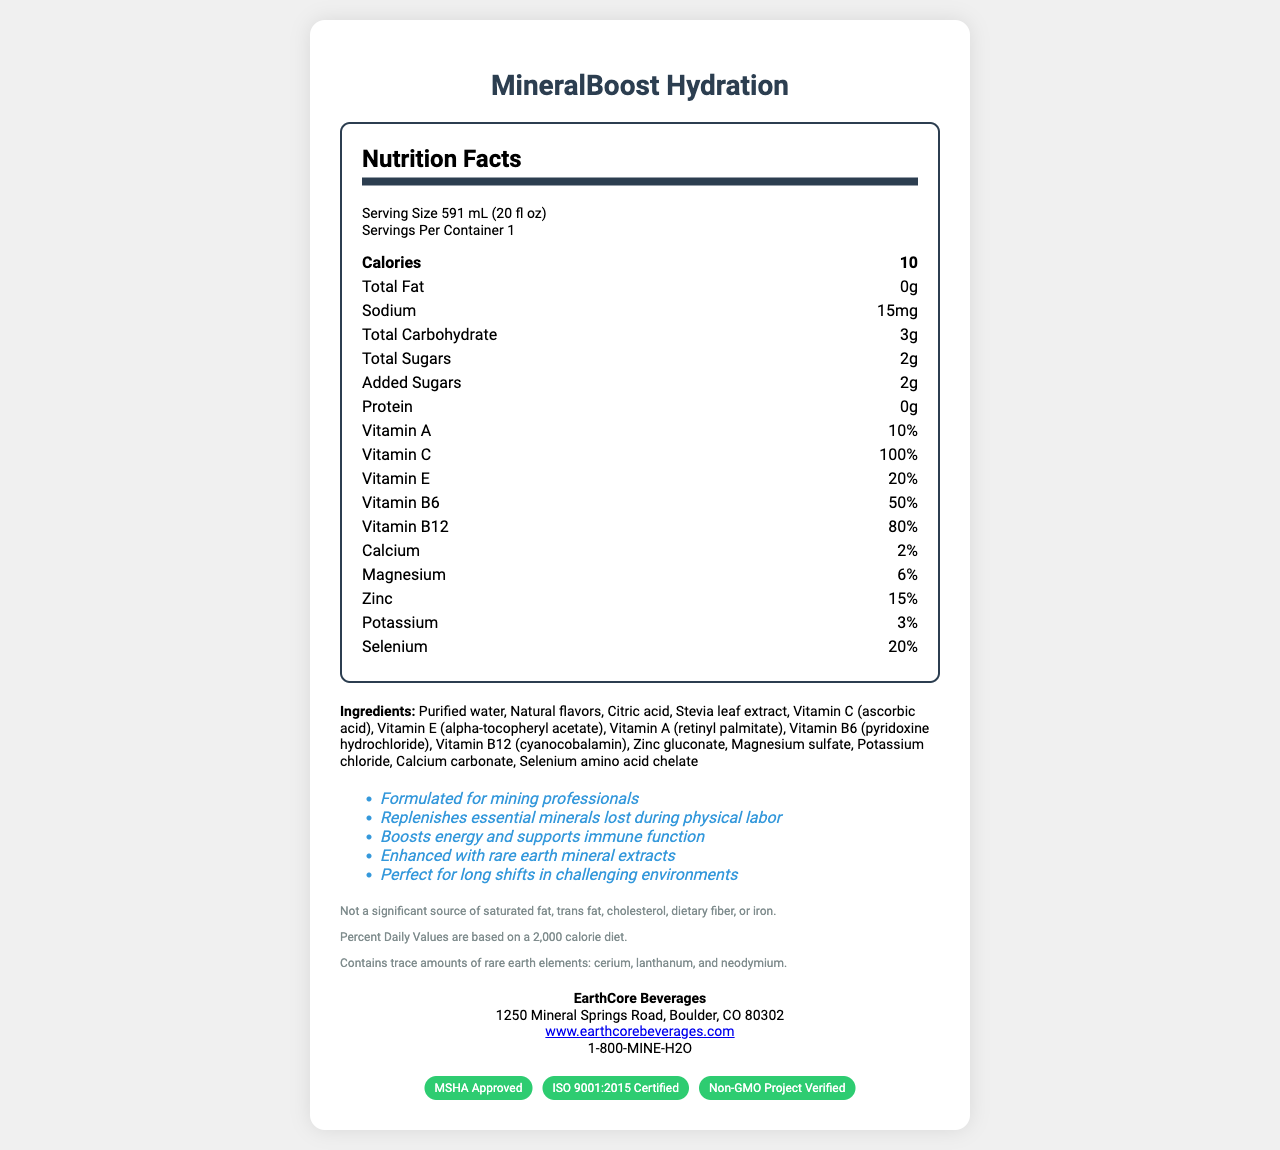What is the serving size of MineralBoost Hydration? The serving size is clearly indicated at the top of the Nutrition Facts section.
Answer: 591 mL (20 fl oz) How many calories are there per serving? The document lists the calories at the top of the nutrition facts as "10".
Answer: 10 What are the ingredients in MineralBoost Hydration? The ingredients are listed in the ingredients section of the document.
Answer: Purified water, Natural flavors, Citric acid, Stevia leaf extract, Vitamin C (ascorbic acid), Vitamin E (alpha-tocopheryl acetate), Vitamin A (retinyl palmitate), Vitamin B6 (pyridoxine hydrochloride), Vitamin B12 (cyanocobalamin), Zinc gluconate, Magnesium sulfate, Potassium chloride, Calcium carbonate, Selenium amino acid chelate What is the percentage of daily Vitamin C provided by MineralBoost Hydration? The nutrition facts list Vitamin C as providing 100% of the daily value.
Answer: 100% Who manufactures MineralBoost Hydration? The manufacturer's information is listed near the bottom of the document.
Answer: EarthCore Beverages (Short-answer) How much sodium is in one serving of MineralBoost Hydration? The nutrition facts list sodium content as 15mg per serving.
Answer: 15mg (Short-answer) What are the marketing claims made by MineralBoost Hydration? The marketing claims are listed in the claims section of the document.
Answer: 1. Formulated for mining professionals 2. Replenishes essential minerals lost during physical labor 3. Boosts energy and supports immune function 4. Enhanced with rare earth mineral extracts 5. Perfect for long shifts in challenging environments (Short-answer) What certifications does MineralBoost Hydration have? The certifications are listed at the bottom of the document under the certifications section.
Answer: MSHA Approved, ISO 9001:2015 Certified, Non-GMO Project Verified (Short-answer) What rare earth elements are trace amounts of in MineralBoost Hydration? The disclaimers section mentions that the product contains trace amounts of rare earth elements: cerium, lanthanum, and neodymium.
Answer: Cerium, Lanthanum, Neodymium (Yes/No) Does MineralBoost Hydration contain any protein? The nutrition facts specifically state that there is 0g of protein in the product.
Answer: No (Multiple-choice) What amount of Vitamin B6 is in this product as a percentage of daily value? 
A. 10% 
B. 80% 
C. 50% The nutrition facts list Vitamin B6 as providing 50% of the daily value.
Answer: C (Multiple-choice) Which of the following minerals is present in the smallest percentage of daily value in MineralBoost Hydration? 
1. Calcium 
2. Magnesium 
3. Zinc 
4. Potassium The nutrition facts list Calcium as 2%, Magnesium as 6%, Zinc as 15%, and Potassium as 3%. Therefore, Calcium is present in the smallest percentage of daily value.
Answer: 1 (Summary) Summarize the main purposes and notable aspects of this vitamin-enhanced water product. The summary captures the main idea that MineralBoost Hydration targets mining professionals with its blend of vitamins, minerals, and claims of replenishing and energy-boosting effects. It also mentions its certifications.
Answer: MineralBoost Hydration is a vitamin-enhanced water specifically formulated for mining professionals. It contains 10 calories per serving and offers various vitamins and minerals including 100% of the daily value of Vitamin C, and significant percentages of several B vitamins, Vitamin E, and Vitamin A. It also includes minor amounts of rare earth elements like cerium, lanthanum, and neodymium. The product is marketed as replenishing essential minerals lost during physical labor, boosting energy, and supporting immune function, and is MSHA Approved, ISO 9001:2015 Certified, and Non-GMO Project Verified. (Unanswerable) What is the best-selling product line of EarthCore Beverages? The provided document does not contain any information regarding the sales performance of this or any other product line from EarthCore Beverages.
Answer: Cannot be determined 